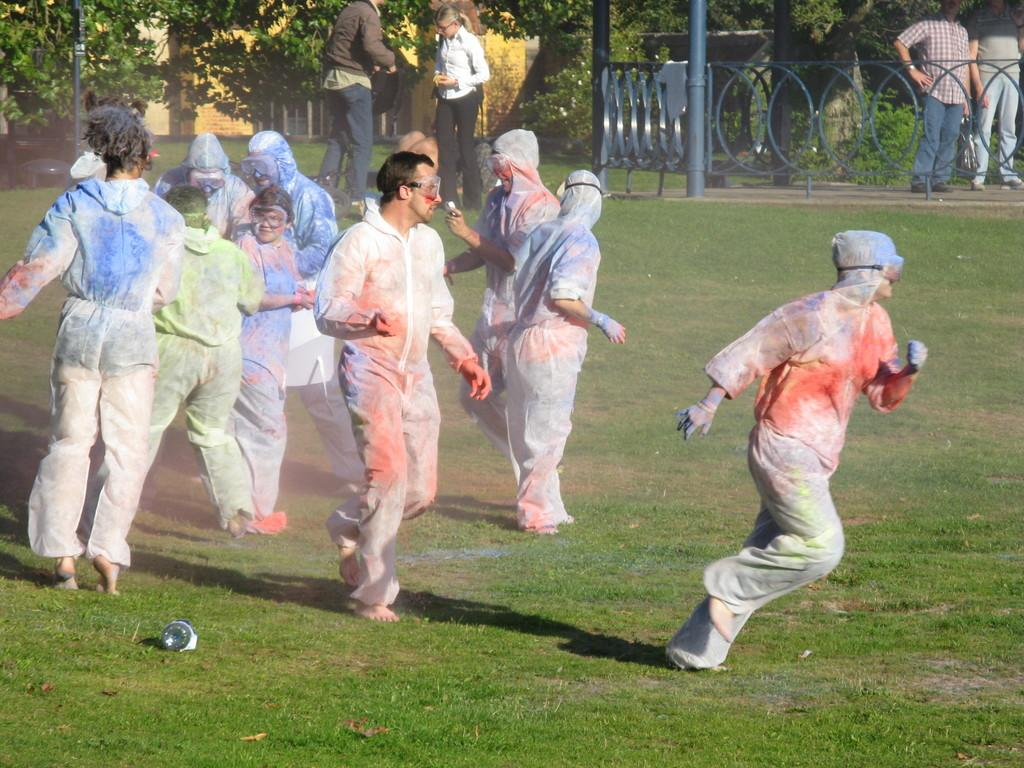What are the people in the image doing? People are playing with colors in the image. Where is this activity taking place? The scene takes place in a park. What can be seen in the background of the image? There is a fencing in the background of the image, and there are persons standing in the background with trees visible behind them. How many cows are visible in the image? There are no cows present in the image. What is the color of the arm of the person standing in the background? The image does not provide enough detail to determine the color of the arm of the person standing in the background. 